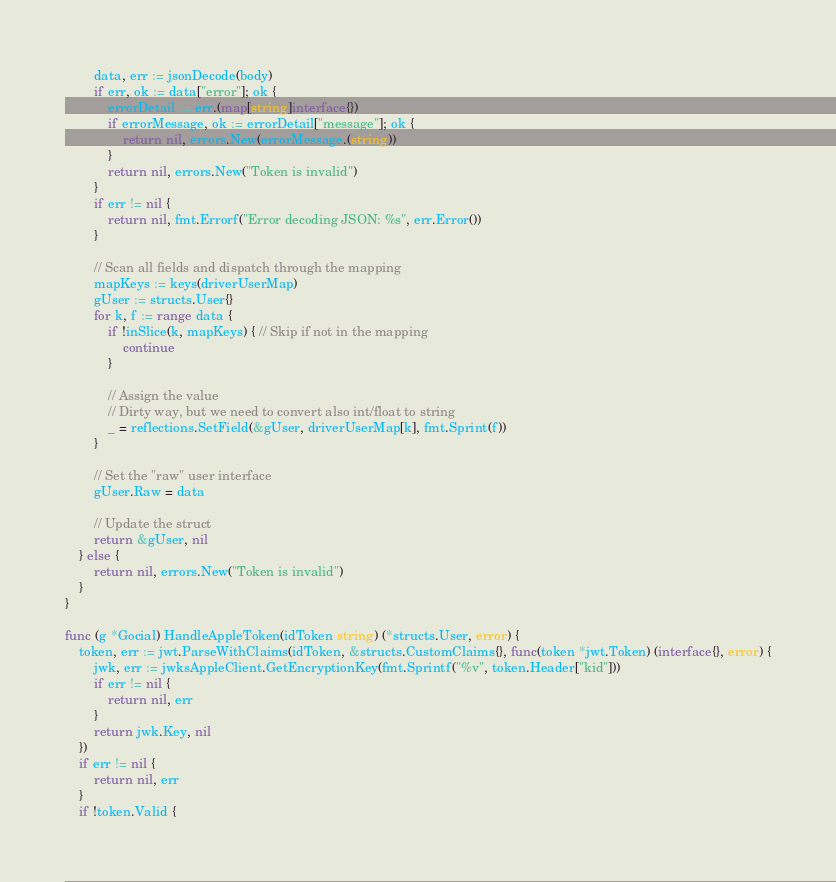<code> <loc_0><loc_0><loc_500><loc_500><_Go_>		data, err := jsonDecode(body)
		if err, ok := data["error"]; ok {
			errorDetail := err.(map[string]interface{})
			if errorMessage, ok := errorDetail["message"]; ok {
				return nil, errors.New(errorMessage.(string))
			}
			return nil, errors.New("Token is invalid")
		}
		if err != nil {
			return nil, fmt.Errorf("Error decoding JSON: %s", err.Error())
		}

		// Scan all fields and dispatch through the mapping
		mapKeys := keys(driverUserMap)
		gUser := structs.User{}
		for k, f := range data {
			if !inSlice(k, mapKeys) { // Skip if not in the mapping
				continue
			}

			// Assign the value
			// Dirty way, but we need to convert also int/float to string
			_ = reflections.SetField(&gUser, driverUserMap[k], fmt.Sprint(f))
		}

		// Set the "raw" user interface
		gUser.Raw = data

		// Update the struct
		return &gUser, nil
	} else {
		return nil, errors.New("Token is invalid")
	}
}

func (g *Gocial) HandleAppleToken(idToken string) (*structs.User, error) {
	token, err := jwt.ParseWithClaims(idToken, &structs.CustomClaims{}, func(token *jwt.Token) (interface{}, error) {
		jwk, err := jwksAppleClient.GetEncryptionKey(fmt.Sprintf("%v", token.Header["kid"]))
		if err != nil {
			return nil, err
		}
		return jwk.Key, nil
	})
	if err != nil {
		return nil, err
	}
	if !token.Valid {</code> 